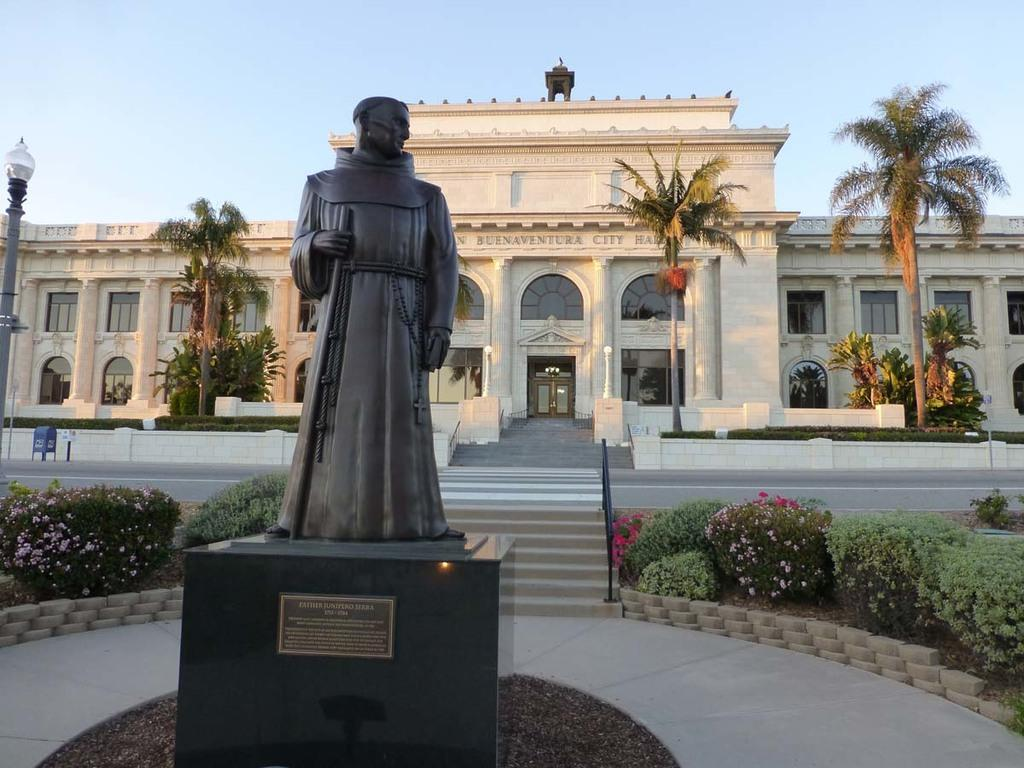What is the main subject in the foreground of the image? There is a sculpture on a headstone in the foreground. What type of vegetation can be seen in the image? There are plants in the image. What architectural feature is present in the image? There are stairs in the image. What can be seen in the background of the image? There are trees, a building, lamp poles, and the sky visible in the background. Can you hear a goose whistling in the image? There is no goose or whistling present in the image. What type of cemetery is depicted in the image? The image does not depict a cemetery; it features a sculpture on a headstone, plants, stairs, and a background with trees, a building, lamp poles, and the sky. 